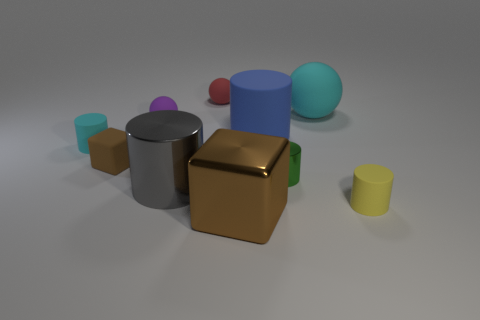Subtract all cyan cylinders. How many cylinders are left? 4 Subtract all big metallic cylinders. How many cylinders are left? 4 Subtract 1 balls. How many balls are left? 2 Subtract all purple cylinders. Subtract all purple cubes. How many cylinders are left? 5 Subtract all spheres. How many objects are left? 7 Add 2 cyan cylinders. How many cyan cylinders are left? 3 Add 4 small things. How many small things exist? 10 Subtract 0 brown balls. How many objects are left? 10 Subtract all tiny red balls. Subtract all small cyan objects. How many objects are left? 8 